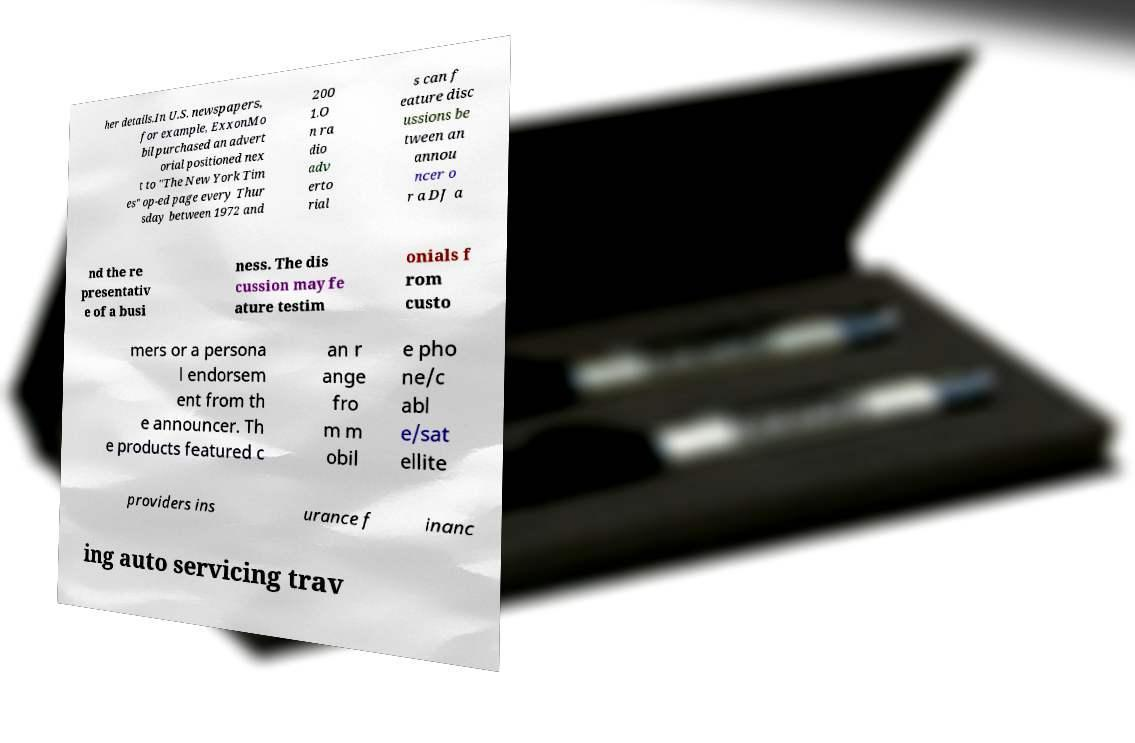There's text embedded in this image that I need extracted. Can you transcribe it verbatim? her details.In U.S. newspapers, for example, ExxonMo bil purchased an advert orial positioned nex t to "The New York Tim es" op-ed page every Thur sday between 1972 and 200 1.O n ra dio adv erto rial s can f eature disc ussions be tween an annou ncer o r a DJ a nd the re presentativ e of a busi ness. The dis cussion may fe ature testim onials f rom custo mers or a persona l endorsem ent from th e announcer. Th e products featured c an r ange fro m m obil e pho ne/c abl e/sat ellite providers ins urance f inanc ing auto servicing trav 